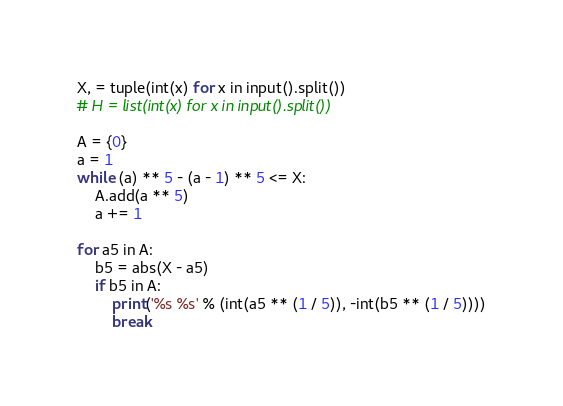<code> <loc_0><loc_0><loc_500><loc_500><_Cython_>X, = tuple(int(x) for x in input().split())
# H = list(int(x) for x in input().split())

A = {0}
a = 1
while (a) ** 5 - (a - 1) ** 5 <= X:
    A.add(a ** 5)
    a += 1

for a5 in A:
    b5 = abs(X - a5)
    if b5 in A:
        print('%s %s' % (int(a5 ** (1 / 5)), -int(b5 ** (1 / 5))))
        break
</code> 